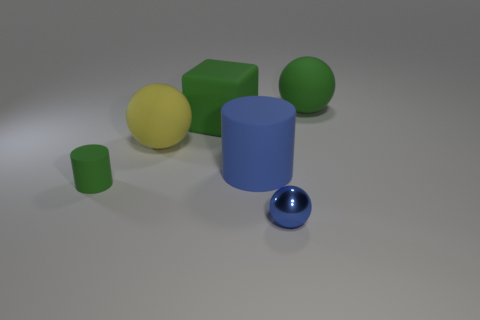Add 2 tiny green rubber cylinders. How many objects exist? 8 Subtract all blocks. How many objects are left? 5 Subtract 1 yellow spheres. How many objects are left? 5 Subtract all small green rubber things. Subtract all green cubes. How many objects are left? 4 Add 6 blue matte objects. How many blue matte objects are left? 7 Add 4 red metallic cubes. How many red metallic cubes exist? 4 